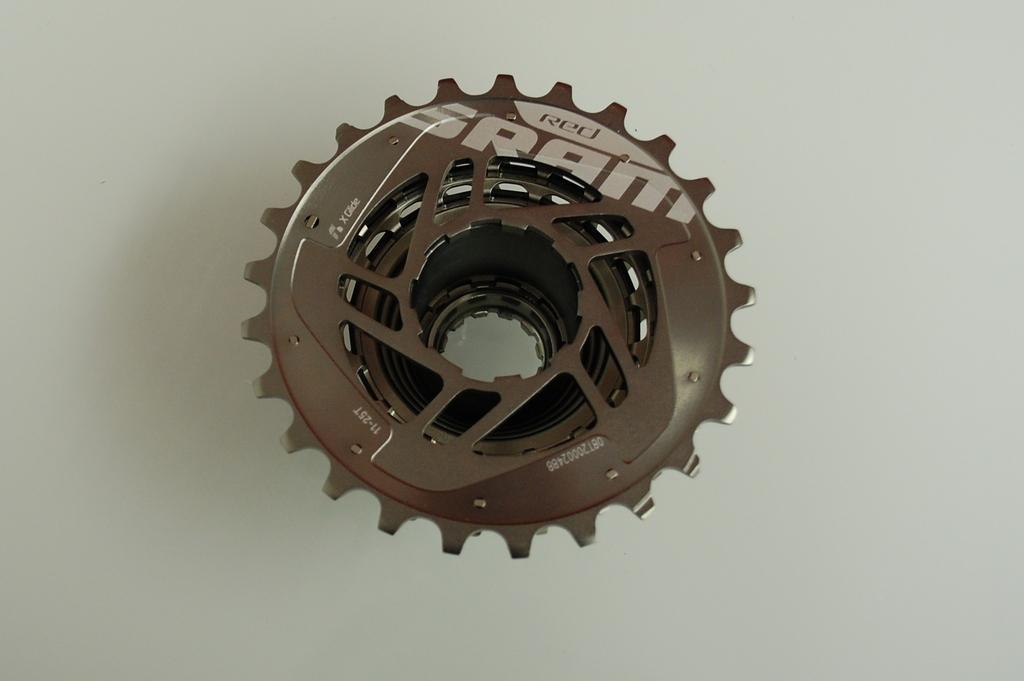In one or two sentences, can you explain what this image depicts? In this image, we can see a gear like object, there is white background. 